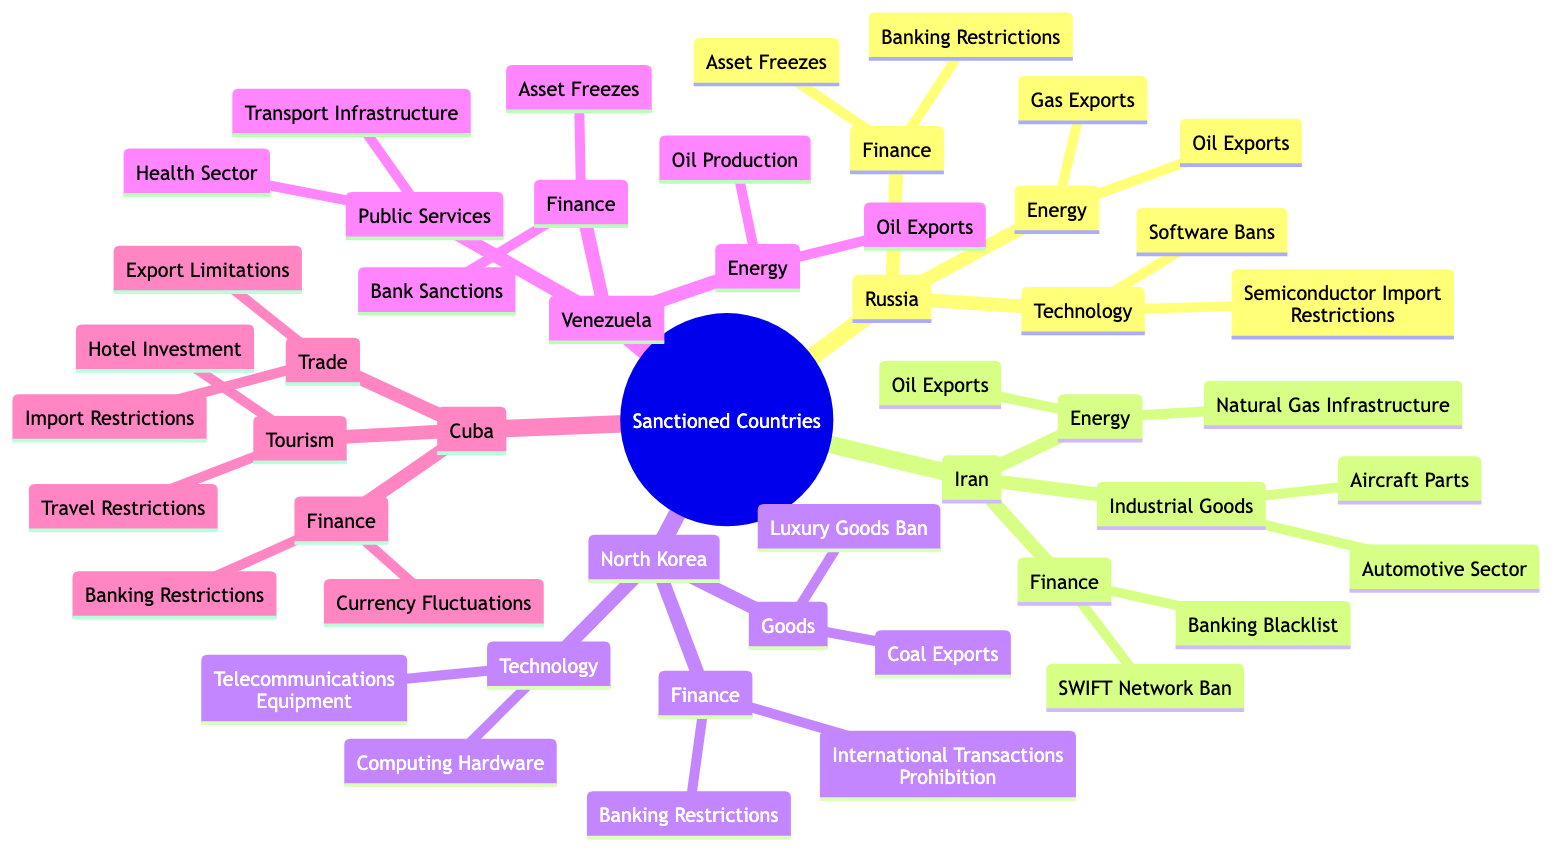What are the key energy sectors affected in Russia? The diagram indicates that the key energy sectors affected in Russia are Oil Exports and Gas Exports, which are listed under the Energy category.
Answer: Oil Exports, Gas Exports How many sectors are affected in Iran? In the diagram, Iran has three sectors listed that are affected: Energy, Finance, and Industrial Goods. Thus, the total number of sectors affected is three.
Answer: 3 Which country has restrictions on telecommunications equipment? The diagram shows that North Korea has restrictions on Telecommunications Equipment, which falls under the Technology sector for that country.
Answer: North Korea What financial restrictions apply to Venezuela? Venezuela faces two key financial restrictions as indicated in the diagram: Bank Sanctions and Asset Freezes, both categorized under the Finance sector.
Answer: Bank Sanctions, Asset Freezes Which country has both oil exports and natural gas infrastructure affected by sanctions? The diagram reveals that Iran has sanctions affecting both Oil Exports and Natural Gas Infrastructure in its Energy sector.
Answer: Iran What type of restrictions does Cuba face in Tourism? The diagram outlines that Cuba faces two types of restrictions in Tourism: Travel Restrictions and Hotel Investment, both listed under the Tourism category.
Answer: Travel Restrictions, Hotel Investment How many types of goods are banned in North Korea? According to the diagram, North Korea has two types of goods banned: Luxury Goods Ban and Coal Exports as shown in the Goods category, which totals to two types.
Answer: 2 What are the two specific areas under the Finance sector for Russia? The diagram delineates that the Finance sector for Russia includes Banking Restrictions and Asset Freezes as specific areas affected by sanctions.
Answer: Banking Restrictions, Asset Freezes Which sanctioned country faces restrictions on currency fluctuations? The diagram indicates that Cuba faces restrictions on Currency Fluctuations under the Finance sector.
Answer: Cuba 